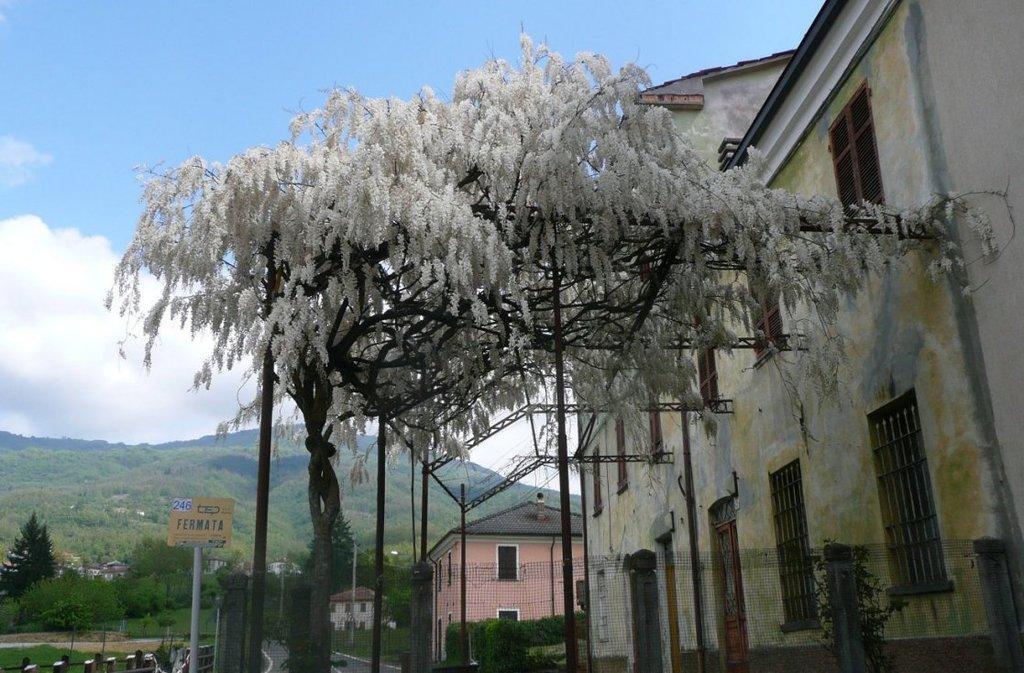Please provide a concise description of this image. In this picture, it seems like a flower climber in the center, there is a building structure on the right side, there are poles, houses, trees, mountains and the sky in the background. 